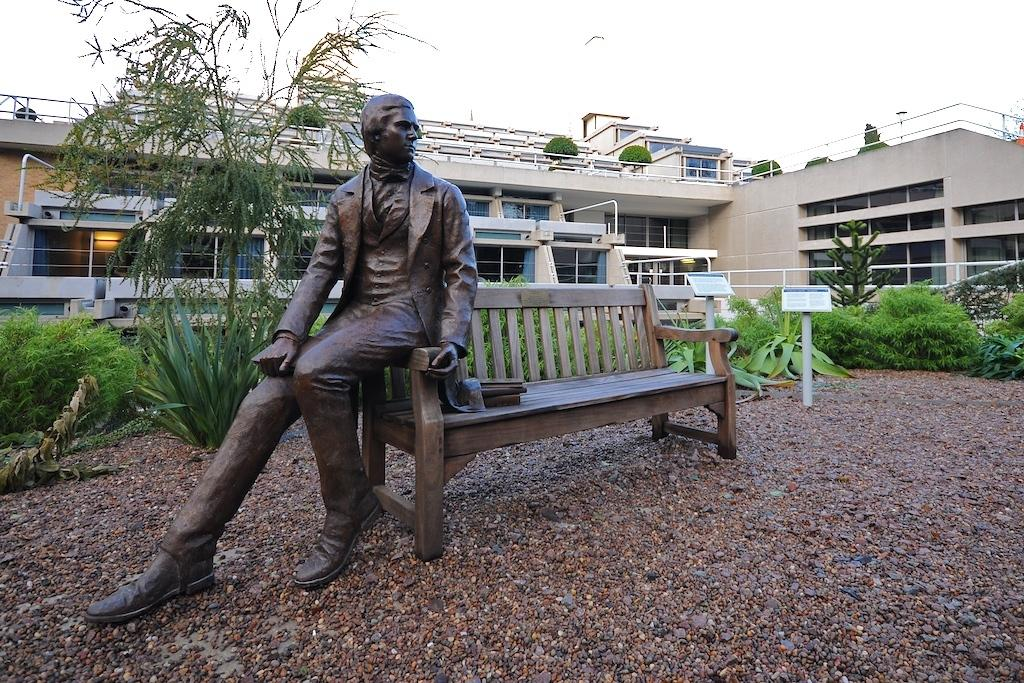What is located in the middle of the image? There is a bench in the middle of the image. What can be seen on the left side of the image? There is a statue of a man on the left side of the image. What is visible in the background of the image? There is a house, plants, a board, the sky, and a bird in the background of the image. How many cars can be seen driving on the road in the image? There are no cars or roads present in the image. Is there a river or stream visible in the image? There is no water feature, such as a river or stream, visible in the image. 